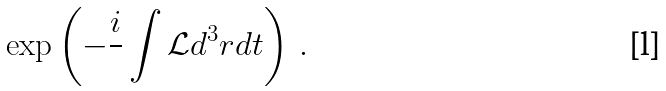Convert formula to latex. <formula><loc_0><loc_0><loc_500><loc_500>\exp \left ( - \frac { i } { } \int \mathcal { L } d ^ { 3 } r d t \right ) \, .</formula> 